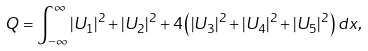<formula> <loc_0><loc_0><loc_500><loc_500>Q = \int _ { - \infty } ^ { \infty } | U _ { 1 } | ^ { 2 } + | U _ { 2 } | ^ { 2 } + 4 \left ( | U _ { 3 } | ^ { 2 } + | U _ { 4 } | ^ { 2 } + | U _ { 5 } | ^ { 2 } \right ) d x ,</formula> 